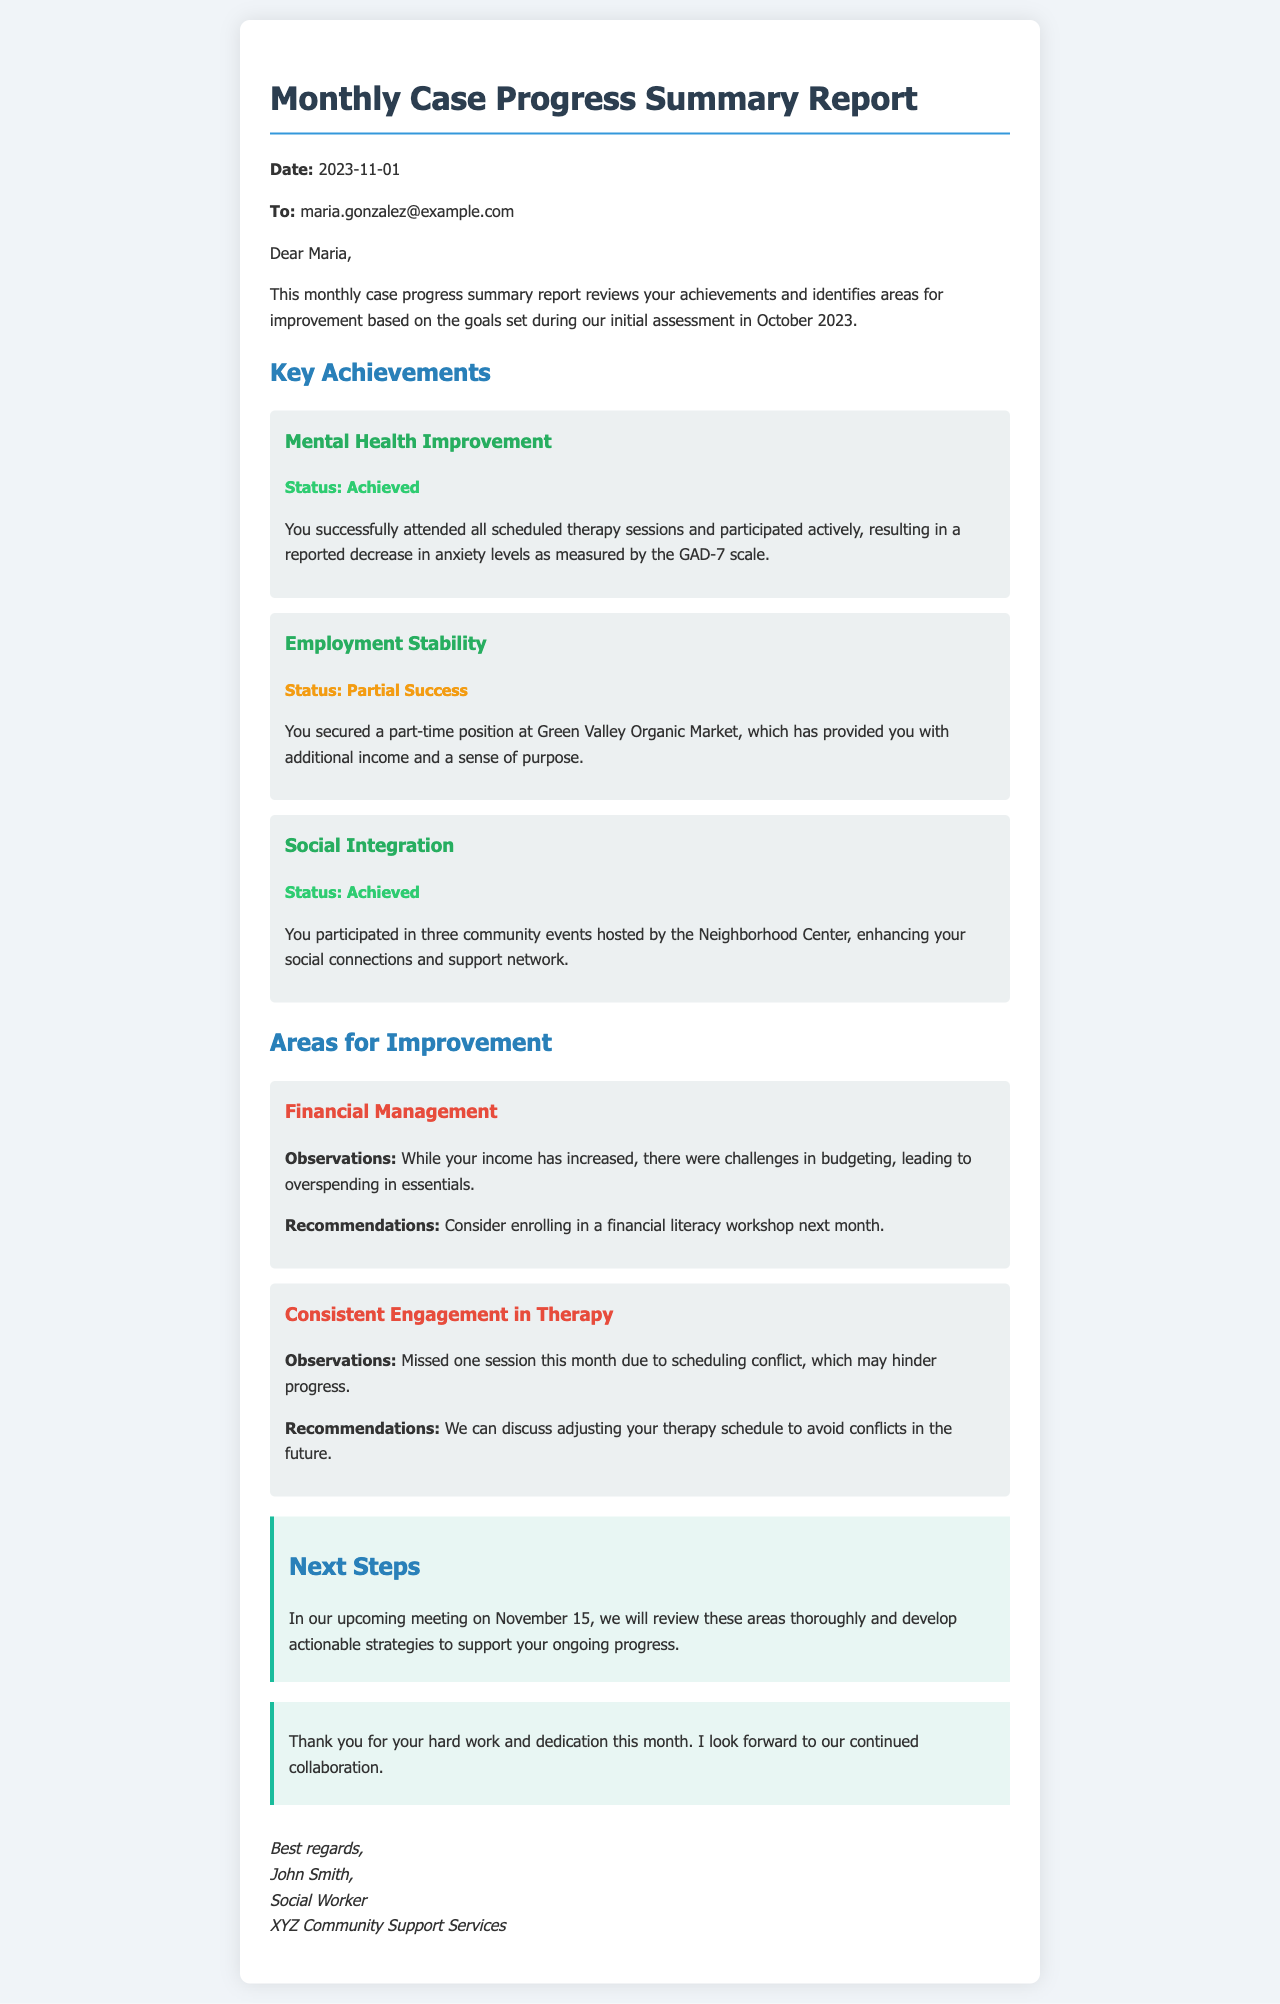What is the date of the report? The date is specified at the beginning of the document under "Date."
Answer: 2023-11-01 Who is the recipient of the report? The recipient's email address is given in the "To" section of the document.
Answer: maria.gonzalez@example.com What was achieved in "Mental Health Improvement"? The achievement is described in detail under "Key Achievements."
Answer: Status: Achieved What is the primary recommendation for "Financial Management"? The recommendation is mentioned in the "Areas for Improvement" section following "Financial Management."
Answer: Enrolling in a financial literacy workshop How many community events did the client participate in? The number of community events attended is stated in "Social Integration" under "Key Achievements."
Answer: Three What was noted about the client's engagement in therapy? The observation is summarized in the "Consistent Engagement in Therapy" improvement section.
Answer: Missed one session What will be addressed in the upcoming meeting? The planned discussion topics are mentioned in the "Next Steps" section of the document.
Answer: Actionable strategies What is the sender's name? The sender's name is provided at the end of the document in the signature.
Answer: John Smith 